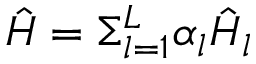Convert formula to latex. <formula><loc_0><loc_0><loc_500><loc_500>\hat { H } = \Sigma _ { l = 1 } ^ { L } \alpha _ { l } \hat { H } _ { l }</formula> 